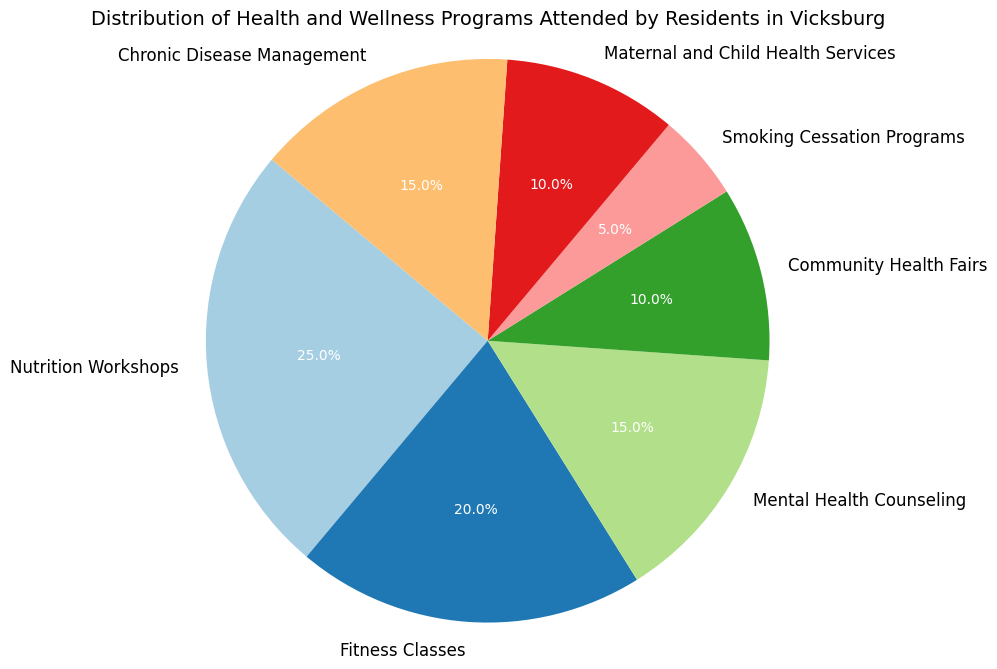Which program has the highest percentage of attendance? The program with the highest percentage of attendance can be identified by looking at the largest slice in the pie chart. In this case, it is 'Nutrition Workshops' with 25%.
Answer: Nutrition Workshops Which two programs combined have the lowest percentage of attendance? By examining the pie chart, the programs with the smallest slices are 'Smoking Cessation Programs' (5%) and 'Community Health Fairs' (10%). Their combined percentage is the sum of these two values: 5% + 10% = 15%.
Answer: Smoking Cessation Programs and Community Health Fairs What is the total percentage of attendance for programs related to disease management? The relevant programs are 'Chronic Disease Management' (15%) and 'Smoking Cessation Programs' (5%). Summing these percentages: 15% + 5% = 20%.
Answer: 20% Of 'Fitness Classes' and 'Mental Health Counseling', which one has a higher percentage of attendance? By comparing the slices corresponding to these programs, 'Fitness Classes' has 20% while 'Mental Health Counseling' has 15%. Therefore, 'Fitness Classes' has a higher attendance.
Answer: Fitness Classes What is the percentage difference between 'Nutrition Workshops' and 'Maternal and Child Health Services'? To find the difference, subtract the percentage of 'Maternal and Child Health Services' (10%) from 'Nutrition Workshops' (25%): 25% - 10% = 15%.
Answer: 15% Which color represents 'Fitness Classes' and what is its percentage of attendance? By locating 'Fitness Classes' in the pie chart and noting its color, then checking the corresponding slice's percentage: 'Fitness Classes' is represented with a specific color and has 20%.
Answer: 20% Between 'Fitness Classes', 'Community Health Fairs', and 'Chronic Disease Management', which has the lowest percentage of attendance? Comparing the three programs' slices, 'Community Health Fairs' has 10%, which is less than 'Fitness Classes' (20%) and 'Chronic Disease Management' (15%).
Answer: Community Health Fairs How many programs have attendance percentages greater than 10%? By examining the pie chart, the programs with percentages greater than 10% are 'Nutrition Workshops' (25%), 'Fitness Classes' (20%), 'Mental Health Counseling' (15%), and 'Chronic Disease Management' (15%). This totals four programs.
Answer: 4 What visual differences can you observe between 'Nutrition Workshops' and 'Smoking Cessation Programs'? 'Nutrition Workshops' has the largest slice in the pie chart, indicating the highest percentage, and is visually predominant. In contrast, 'Smoking Cessation Programs' has one of the smallest slices, showing a much smaller percentage.
Answer: Largest vs. Smallest Slices 